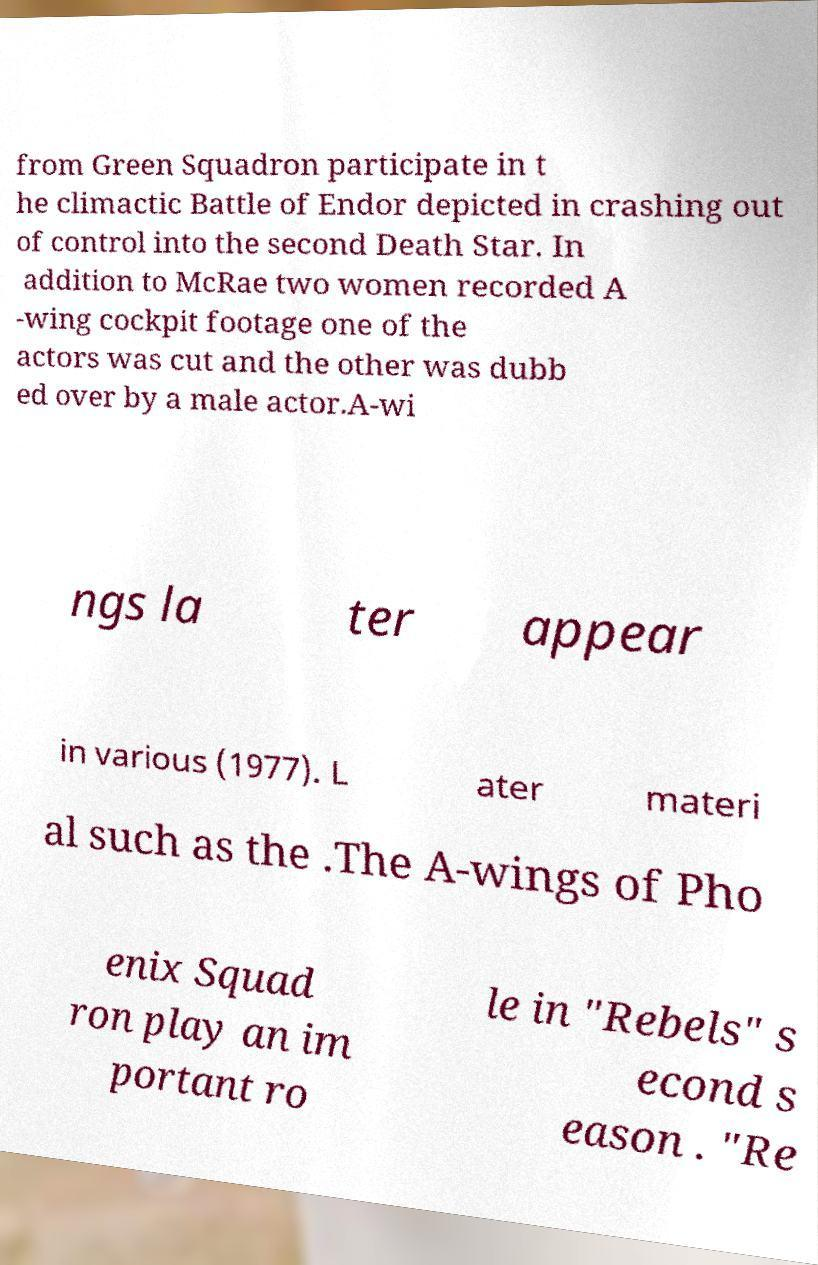Please identify and transcribe the text found in this image. from Green Squadron participate in t he climactic Battle of Endor depicted in crashing out of control into the second Death Star. In addition to McRae two women recorded A -wing cockpit footage one of the actors was cut and the other was dubb ed over by a male actor.A-wi ngs la ter appear in various (1977). L ater materi al such as the .The A-wings of Pho enix Squad ron play an im portant ro le in "Rebels" s econd s eason . "Re 